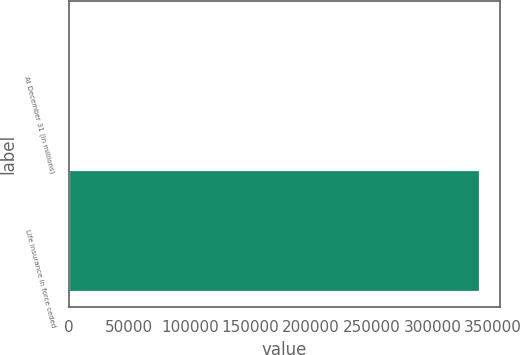Convert chart to OTSL. <chart><loc_0><loc_0><loc_500><loc_500><bar_chart><fcel>At December 31 (in millions)<fcel>Life insurance in force ceded<nl><fcel>2009<fcel>339183<nl></chart> 